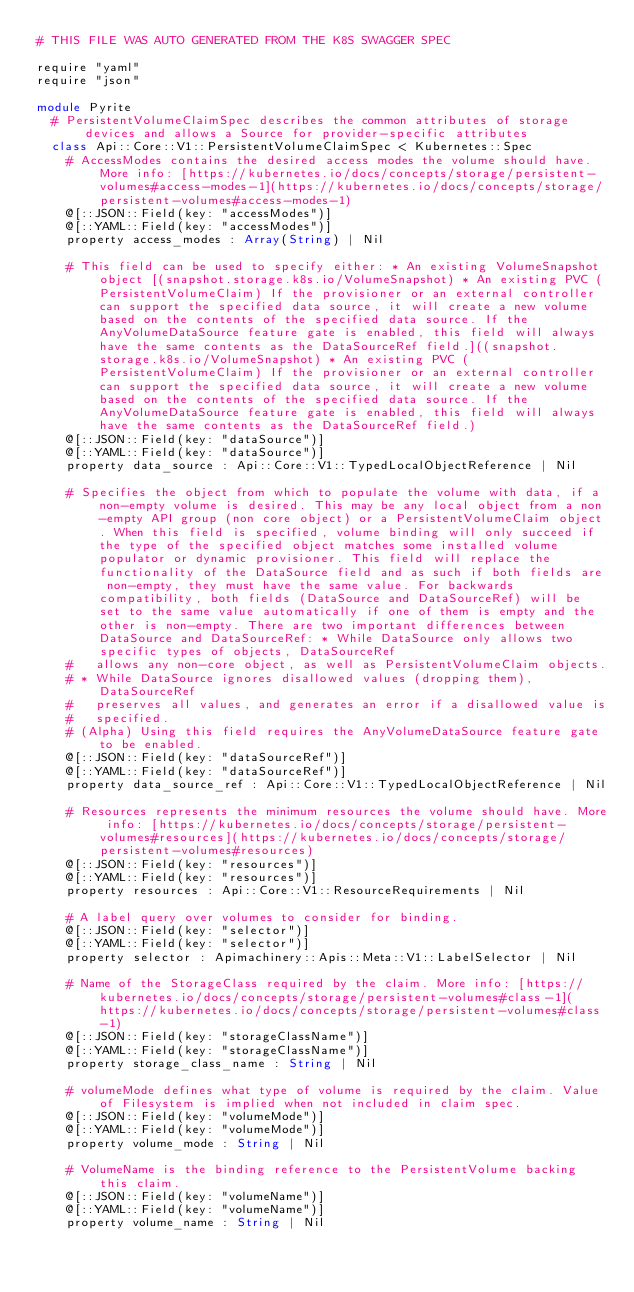<code> <loc_0><loc_0><loc_500><loc_500><_Crystal_># THIS FILE WAS AUTO GENERATED FROM THE K8S SWAGGER SPEC

require "yaml"
require "json"

module Pyrite
  # PersistentVolumeClaimSpec describes the common attributes of storage devices and allows a Source for provider-specific attributes
  class Api::Core::V1::PersistentVolumeClaimSpec < Kubernetes::Spec
    # AccessModes contains the desired access modes the volume should have. More info: [https://kubernetes.io/docs/concepts/storage/persistent-volumes#access-modes-1](https://kubernetes.io/docs/concepts/storage/persistent-volumes#access-modes-1)
    @[::JSON::Field(key: "accessModes")]
    @[::YAML::Field(key: "accessModes")]
    property access_modes : Array(String) | Nil

    # This field can be used to specify either: * An existing VolumeSnapshot object [(snapshot.storage.k8s.io/VolumeSnapshot) * An existing PVC (PersistentVolumeClaim) If the provisioner or an external controller can support the specified data source, it will create a new volume based on the contents of the specified data source. If the AnyVolumeDataSource feature gate is enabled, this field will always have the same contents as the DataSourceRef field.]((snapshot.storage.k8s.io/VolumeSnapshot) * An existing PVC (PersistentVolumeClaim) If the provisioner or an external controller can support the specified data source, it will create a new volume based on the contents of the specified data source. If the AnyVolumeDataSource feature gate is enabled, this field will always have the same contents as the DataSourceRef field.)
    @[::JSON::Field(key: "dataSource")]
    @[::YAML::Field(key: "dataSource")]
    property data_source : Api::Core::V1::TypedLocalObjectReference | Nil

    # Specifies the object from which to populate the volume with data, if a non-empty volume is desired. This may be any local object from a non-empty API group (non core object) or a PersistentVolumeClaim object. When this field is specified, volume binding will only succeed if the type of the specified object matches some installed volume populator or dynamic provisioner. This field will replace the functionality of the DataSource field and as such if both fields are non-empty, they must have the same value. For backwards compatibility, both fields (DataSource and DataSourceRef) will be set to the same value automatically if one of them is empty and the other is non-empty. There are two important differences between DataSource and DataSourceRef: * While DataSource only allows two specific types of objects, DataSourceRef
    #   allows any non-core object, as well as PersistentVolumeClaim objects.
    # * While DataSource ignores disallowed values (dropping them), DataSourceRef
    #   preserves all values, and generates an error if a disallowed value is
    #   specified.
    # (Alpha) Using this field requires the AnyVolumeDataSource feature gate to be enabled.
    @[::JSON::Field(key: "dataSourceRef")]
    @[::YAML::Field(key: "dataSourceRef")]
    property data_source_ref : Api::Core::V1::TypedLocalObjectReference | Nil

    # Resources represents the minimum resources the volume should have. More info: [https://kubernetes.io/docs/concepts/storage/persistent-volumes#resources](https://kubernetes.io/docs/concepts/storage/persistent-volumes#resources)
    @[::JSON::Field(key: "resources")]
    @[::YAML::Field(key: "resources")]
    property resources : Api::Core::V1::ResourceRequirements | Nil

    # A label query over volumes to consider for binding.
    @[::JSON::Field(key: "selector")]
    @[::YAML::Field(key: "selector")]
    property selector : Apimachinery::Apis::Meta::V1::LabelSelector | Nil

    # Name of the StorageClass required by the claim. More info: [https://kubernetes.io/docs/concepts/storage/persistent-volumes#class-1](https://kubernetes.io/docs/concepts/storage/persistent-volumes#class-1)
    @[::JSON::Field(key: "storageClassName")]
    @[::YAML::Field(key: "storageClassName")]
    property storage_class_name : String | Nil

    # volumeMode defines what type of volume is required by the claim. Value of Filesystem is implied when not included in claim spec.
    @[::JSON::Field(key: "volumeMode")]
    @[::YAML::Field(key: "volumeMode")]
    property volume_mode : String | Nil

    # VolumeName is the binding reference to the PersistentVolume backing this claim.
    @[::JSON::Field(key: "volumeName")]
    @[::YAML::Field(key: "volumeName")]
    property volume_name : String | Nil
</code> 